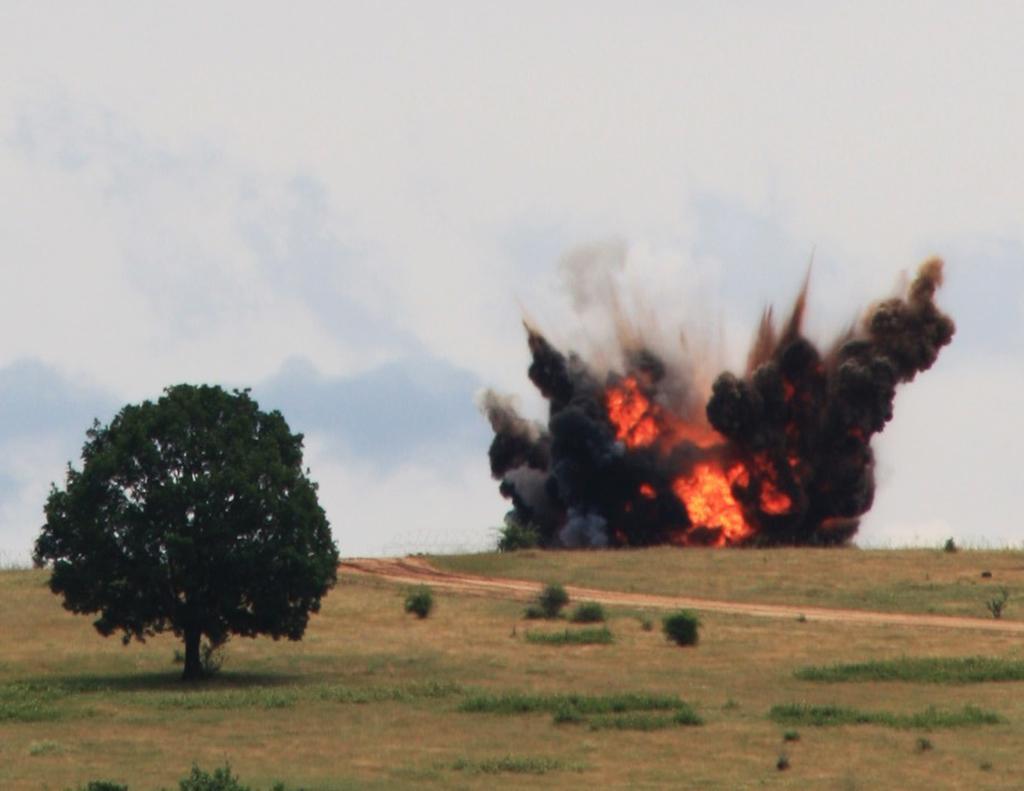How would you summarize this image in a sentence or two? In this image I can see the tree, grass and plants on the ground. To the side I can see the fire and smoke. In the background I can see the clouds and the sky. 